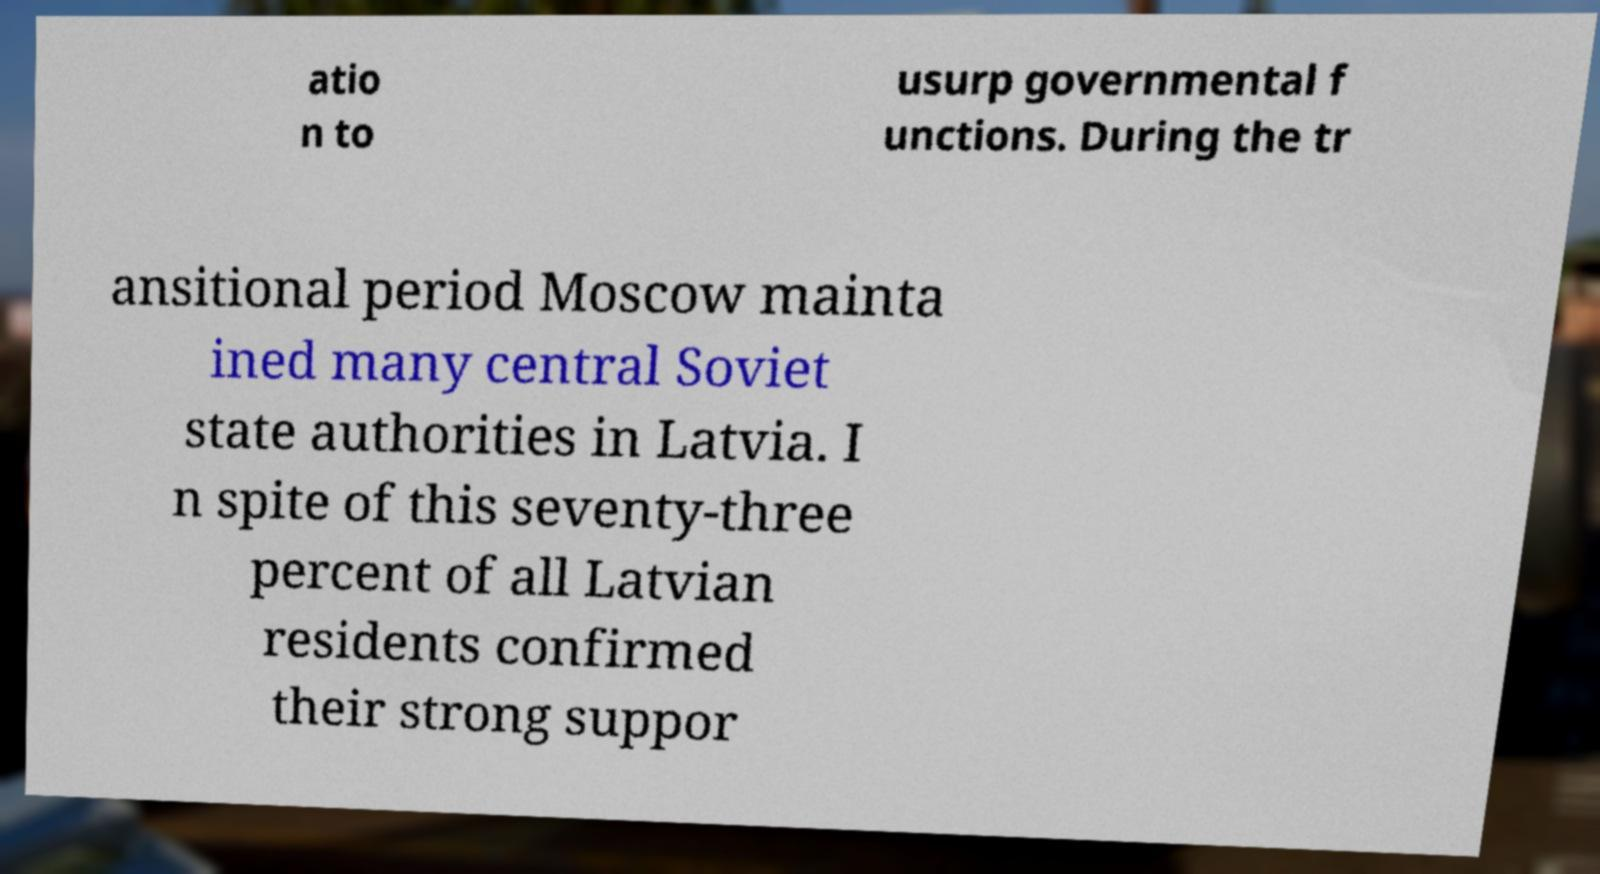Could you assist in decoding the text presented in this image and type it out clearly? atio n to usurp governmental f unctions. During the tr ansitional period Moscow mainta ined many central Soviet state authorities in Latvia. I n spite of this seventy-three percent of all Latvian residents confirmed their strong suppor 